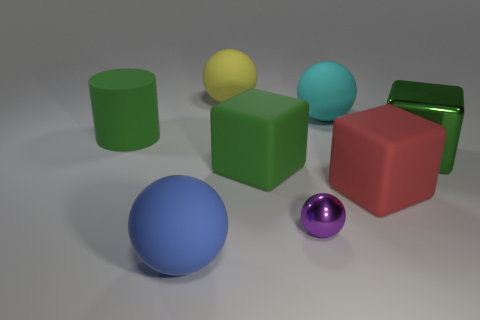Subtract 1 spheres. How many spheres are left? 3 Subtract all purple balls. How many balls are left? 3 Subtract all green cubes. How many cubes are left? 1 Add 1 purple things. How many objects exist? 9 Subtract all red balls. Subtract all blue blocks. How many balls are left? 4 Subtract all cylinders. How many objects are left? 7 Add 3 big blue matte objects. How many big blue matte objects are left? 4 Add 4 small blue shiny cubes. How many small blue shiny cubes exist? 4 Subtract 0 red cylinders. How many objects are left? 8 Subtract all blue objects. Subtract all metal things. How many objects are left? 5 